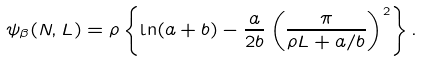Convert formula to latex. <formula><loc_0><loc_0><loc_500><loc_500>\psi _ { \beta } ( N , L ) = \rho \left \{ \ln ( a + b ) - \frac { a } { 2 b } \left ( \frac { \pi } { \rho L + a / b } \right ) ^ { 2 } \right \} .</formula> 